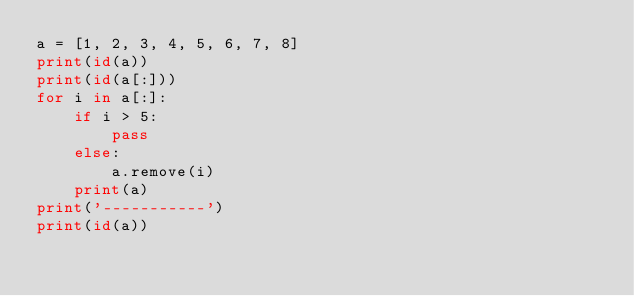Convert code to text. <code><loc_0><loc_0><loc_500><loc_500><_Python_>a = [1, 2, 3, 4, 5, 6, 7, 8]
print(id(a))
print(id(a[:]))
for i in a[:]:
    if i > 5:
        pass
    else:
        a.remove(i)
    print(a)
print('-----------')
print(id(a))
</code> 